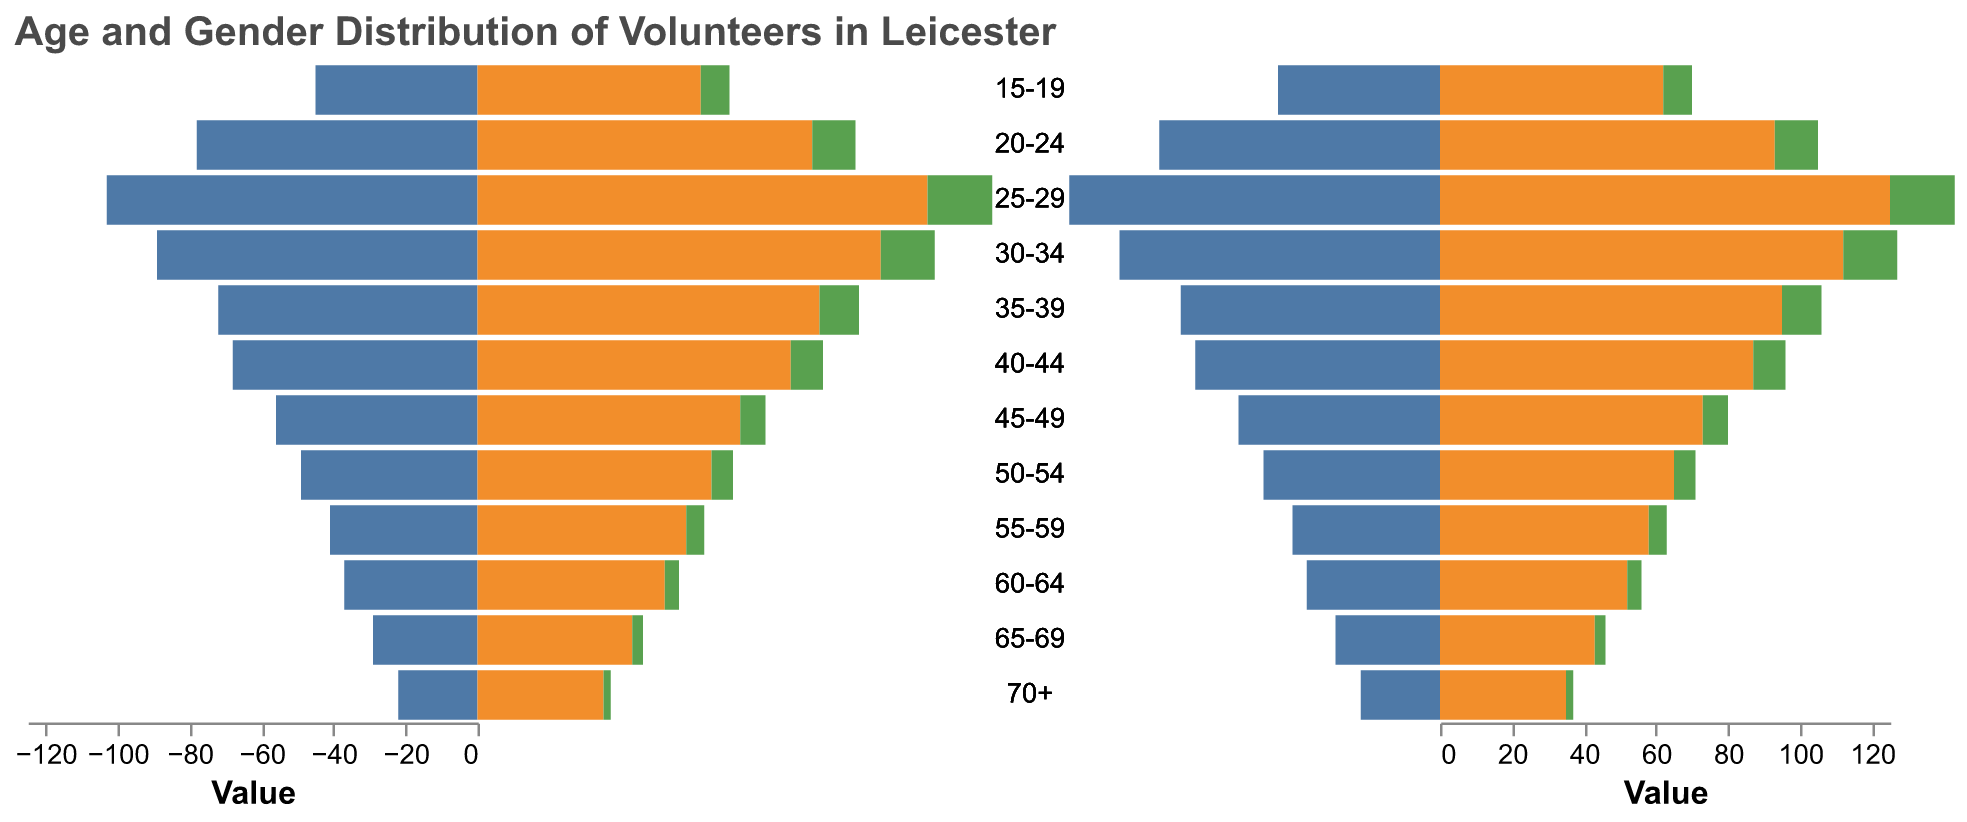Which age group has the highest number of female volunteers? By observing the bars representing each gender across all age groups, we see that the age group 25-29 has the tallest bar for females.
Answer: 25-29 What is the total number of volunteers in the age group 20-24? Add the number of male, female, and non-binary volunteers in the age group 20-24: 78 (male) + 93 (female) + 12 (non-binary) = 183.
Answer: 183 Are there more male or female volunteers in the age group 35-39? Compare the heights of the bars for male and female in the 35-39 age group. Females have 95 volunteers and males have 72.
Answer: Female Which gender has the fewest volunteers overall in every age group? By examining the color legends and evaluating the lengths of the bars, the bars for Non-Binary are consistently shorter compared to those of Male and Female across all age groups.
Answer: Non-Binary What is the difference between the number of male volunteers aged 60-64 and those aged 65-69? Subtract the number of male volunteers aged 65-69 from those aged 60-64: 37 (60-64) - 29 (65-69) = 8.
Answer: 8 Which age group has the equal number of female and non-binary volunteers? By investigating the bars for each age group, the age group 50-54 has 65 female and 6 non-binary volunteers, which does not match. Continue checking all age groups and 70+ is close but not equal. Thus, none match.
Answer: None match What is the ratio of male to female volunteers in the age group 25-29? Divide the number of male volunteers by the number of female volunteers in the age group 25-29: 103 (male) / 125 (female) ≈ 0.824.
Answer: 0.824 Does any age group have more non-binary volunteers than male volunteers? Look at the data for each age group to see if the non-binary numbers are greater than the male numbers. No such age group exists in the dataset.
Answer: No 